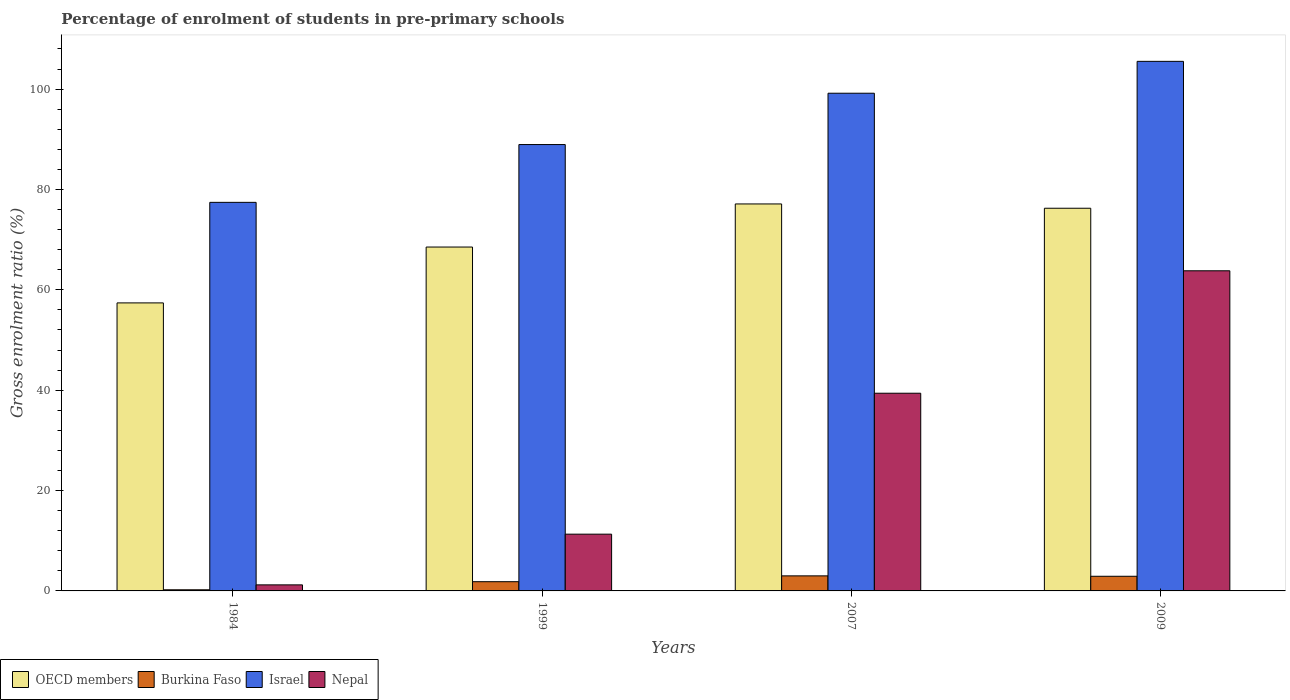How many groups of bars are there?
Make the answer very short. 4. Are the number of bars per tick equal to the number of legend labels?
Your response must be concise. Yes. Are the number of bars on each tick of the X-axis equal?
Offer a terse response. Yes. How many bars are there on the 1st tick from the left?
Your answer should be very brief. 4. How many bars are there on the 2nd tick from the right?
Your response must be concise. 4. What is the label of the 2nd group of bars from the left?
Keep it short and to the point. 1999. In how many cases, is the number of bars for a given year not equal to the number of legend labels?
Offer a very short reply. 0. What is the percentage of students enrolled in pre-primary schools in Israel in 1999?
Offer a terse response. 88.95. Across all years, what is the maximum percentage of students enrolled in pre-primary schools in OECD members?
Give a very brief answer. 77.11. Across all years, what is the minimum percentage of students enrolled in pre-primary schools in Israel?
Your response must be concise. 77.43. In which year was the percentage of students enrolled in pre-primary schools in Nepal minimum?
Offer a very short reply. 1984. What is the total percentage of students enrolled in pre-primary schools in Burkina Faso in the graph?
Your answer should be very brief. 7.98. What is the difference between the percentage of students enrolled in pre-primary schools in Nepal in 1999 and that in 2009?
Provide a short and direct response. -52.49. What is the difference between the percentage of students enrolled in pre-primary schools in Israel in 2007 and the percentage of students enrolled in pre-primary schools in Nepal in 1984?
Offer a very short reply. 97.97. What is the average percentage of students enrolled in pre-primary schools in Nepal per year?
Ensure brevity in your answer.  28.93. In the year 1984, what is the difference between the percentage of students enrolled in pre-primary schools in OECD members and percentage of students enrolled in pre-primary schools in Nepal?
Keep it short and to the point. 56.19. What is the ratio of the percentage of students enrolled in pre-primary schools in OECD members in 1984 to that in 1999?
Offer a terse response. 0.84. Is the percentage of students enrolled in pre-primary schools in Israel in 1999 less than that in 2009?
Your response must be concise. Yes. What is the difference between the highest and the second highest percentage of students enrolled in pre-primary schools in Israel?
Your answer should be very brief. 6.35. What is the difference between the highest and the lowest percentage of students enrolled in pre-primary schools in Burkina Faso?
Offer a terse response. 2.78. In how many years, is the percentage of students enrolled in pre-primary schools in Israel greater than the average percentage of students enrolled in pre-primary schools in Israel taken over all years?
Provide a short and direct response. 2. Is the sum of the percentage of students enrolled in pre-primary schools in Nepal in 1984 and 2007 greater than the maximum percentage of students enrolled in pre-primary schools in Israel across all years?
Provide a succinct answer. No. What does the 2nd bar from the left in 1999 represents?
Ensure brevity in your answer.  Burkina Faso. What does the 1st bar from the right in 1984 represents?
Your answer should be very brief. Nepal. Is it the case that in every year, the sum of the percentage of students enrolled in pre-primary schools in Israel and percentage of students enrolled in pre-primary schools in OECD members is greater than the percentage of students enrolled in pre-primary schools in Nepal?
Provide a succinct answer. Yes. Are all the bars in the graph horizontal?
Give a very brief answer. No. How many years are there in the graph?
Make the answer very short. 4. Does the graph contain any zero values?
Offer a terse response. No. How many legend labels are there?
Your answer should be very brief. 4. What is the title of the graph?
Your answer should be very brief. Percentage of enrolment of students in pre-primary schools. Does "Sudan" appear as one of the legend labels in the graph?
Ensure brevity in your answer.  No. What is the label or title of the Y-axis?
Offer a very short reply. Gross enrolment ratio (%). What is the Gross enrolment ratio (%) in OECD members in 1984?
Give a very brief answer. 57.4. What is the Gross enrolment ratio (%) in Burkina Faso in 1984?
Your answer should be very brief. 0.23. What is the Gross enrolment ratio (%) in Israel in 1984?
Make the answer very short. 77.43. What is the Gross enrolment ratio (%) in Nepal in 1984?
Keep it short and to the point. 1.21. What is the Gross enrolment ratio (%) in OECD members in 1999?
Give a very brief answer. 68.53. What is the Gross enrolment ratio (%) in Burkina Faso in 1999?
Your answer should be compact. 1.84. What is the Gross enrolment ratio (%) of Israel in 1999?
Keep it short and to the point. 88.95. What is the Gross enrolment ratio (%) of Nepal in 1999?
Keep it short and to the point. 11.31. What is the Gross enrolment ratio (%) of OECD members in 2007?
Keep it short and to the point. 77.11. What is the Gross enrolment ratio (%) of Burkina Faso in 2007?
Provide a succinct answer. 3. What is the Gross enrolment ratio (%) of Israel in 2007?
Ensure brevity in your answer.  99.18. What is the Gross enrolment ratio (%) in Nepal in 2007?
Offer a very short reply. 39.4. What is the Gross enrolment ratio (%) in OECD members in 2009?
Keep it short and to the point. 76.26. What is the Gross enrolment ratio (%) in Burkina Faso in 2009?
Offer a terse response. 2.92. What is the Gross enrolment ratio (%) of Israel in 2009?
Offer a terse response. 105.53. What is the Gross enrolment ratio (%) in Nepal in 2009?
Give a very brief answer. 63.8. Across all years, what is the maximum Gross enrolment ratio (%) of OECD members?
Provide a short and direct response. 77.11. Across all years, what is the maximum Gross enrolment ratio (%) in Burkina Faso?
Provide a short and direct response. 3. Across all years, what is the maximum Gross enrolment ratio (%) in Israel?
Provide a succinct answer. 105.53. Across all years, what is the maximum Gross enrolment ratio (%) of Nepal?
Keep it short and to the point. 63.8. Across all years, what is the minimum Gross enrolment ratio (%) in OECD members?
Provide a short and direct response. 57.4. Across all years, what is the minimum Gross enrolment ratio (%) in Burkina Faso?
Provide a succinct answer. 0.23. Across all years, what is the minimum Gross enrolment ratio (%) in Israel?
Provide a succinct answer. 77.43. Across all years, what is the minimum Gross enrolment ratio (%) of Nepal?
Provide a short and direct response. 1.21. What is the total Gross enrolment ratio (%) in OECD members in the graph?
Give a very brief answer. 279.3. What is the total Gross enrolment ratio (%) of Burkina Faso in the graph?
Your answer should be very brief. 7.98. What is the total Gross enrolment ratio (%) of Israel in the graph?
Give a very brief answer. 371.09. What is the total Gross enrolment ratio (%) of Nepal in the graph?
Offer a terse response. 115.71. What is the difference between the Gross enrolment ratio (%) in OECD members in 1984 and that in 1999?
Provide a succinct answer. -11.13. What is the difference between the Gross enrolment ratio (%) of Burkina Faso in 1984 and that in 1999?
Give a very brief answer. -1.61. What is the difference between the Gross enrolment ratio (%) in Israel in 1984 and that in 1999?
Provide a succinct answer. -11.52. What is the difference between the Gross enrolment ratio (%) of Nepal in 1984 and that in 1999?
Your response must be concise. -10.1. What is the difference between the Gross enrolment ratio (%) of OECD members in 1984 and that in 2007?
Your answer should be very brief. -19.72. What is the difference between the Gross enrolment ratio (%) of Burkina Faso in 1984 and that in 2007?
Ensure brevity in your answer.  -2.78. What is the difference between the Gross enrolment ratio (%) of Israel in 1984 and that in 2007?
Your answer should be compact. -21.74. What is the difference between the Gross enrolment ratio (%) of Nepal in 1984 and that in 2007?
Provide a succinct answer. -38.19. What is the difference between the Gross enrolment ratio (%) in OECD members in 1984 and that in 2009?
Your response must be concise. -18.86. What is the difference between the Gross enrolment ratio (%) in Burkina Faso in 1984 and that in 2009?
Your answer should be very brief. -2.69. What is the difference between the Gross enrolment ratio (%) of Israel in 1984 and that in 2009?
Provide a short and direct response. -28.1. What is the difference between the Gross enrolment ratio (%) in Nepal in 1984 and that in 2009?
Offer a terse response. -62.59. What is the difference between the Gross enrolment ratio (%) in OECD members in 1999 and that in 2007?
Your answer should be compact. -8.59. What is the difference between the Gross enrolment ratio (%) of Burkina Faso in 1999 and that in 2007?
Provide a succinct answer. -1.16. What is the difference between the Gross enrolment ratio (%) in Israel in 1999 and that in 2007?
Offer a terse response. -10.23. What is the difference between the Gross enrolment ratio (%) of Nepal in 1999 and that in 2007?
Offer a terse response. -28.09. What is the difference between the Gross enrolment ratio (%) of OECD members in 1999 and that in 2009?
Keep it short and to the point. -7.73. What is the difference between the Gross enrolment ratio (%) in Burkina Faso in 1999 and that in 2009?
Provide a short and direct response. -1.08. What is the difference between the Gross enrolment ratio (%) in Israel in 1999 and that in 2009?
Provide a succinct answer. -16.58. What is the difference between the Gross enrolment ratio (%) of Nepal in 1999 and that in 2009?
Provide a succinct answer. -52.49. What is the difference between the Gross enrolment ratio (%) in OECD members in 2007 and that in 2009?
Give a very brief answer. 0.86. What is the difference between the Gross enrolment ratio (%) in Burkina Faso in 2007 and that in 2009?
Your answer should be compact. 0.08. What is the difference between the Gross enrolment ratio (%) in Israel in 2007 and that in 2009?
Offer a very short reply. -6.35. What is the difference between the Gross enrolment ratio (%) in Nepal in 2007 and that in 2009?
Your answer should be compact. -24.4. What is the difference between the Gross enrolment ratio (%) in OECD members in 1984 and the Gross enrolment ratio (%) in Burkina Faso in 1999?
Your response must be concise. 55.56. What is the difference between the Gross enrolment ratio (%) of OECD members in 1984 and the Gross enrolment ratio (%) of Israel in 1999?
Offer a very short reply. -31.55. What is the difference between the Gross enrolment ratio (%) in OECD members in 1984 and the Gross enrolment ratio (%) in Nepal in 1999?
Keep it short and to the point. 46.09. What is the difference between the Gross enrolment ratio (%) of Burkina Faso in 1984 and the Gross enrolment ratio (%) of Israel in 1999?
Give a very brief answer. -88.72. What is the difference between the Gross enrolment ratio (%) of Burkina Faso in 1984 and the Gross enrolment ratio (%) of Nepal in 1999?
Keep it short and to the point. -11.08. What is the difference between the Gross enrolment ratio (%) in Israel in 1984 and the Gross enrolment ratio (%) in Nepal in 1999?
Give a very brief answer. 66.12. What is the difference between the Gross enrolment ratio (%) of OECD members in 1984 and the Gross enrolment ratio (%) of Burkina Faso in 2007?
Your response must be concise. 54.39. What is the difference between the Gross enrolment ratio (%) in OECD members in 1984 and the Gross enrolment ratio (%) in Israel in 2007?
Keep it short and to the point. -41.78. What is the difference between the Gross enrolment ratio (%) in OECD members in 1984 and the Gross enrolment ratio (%) in Nepal in 2007?
Your response must be concise. 18. What is the difference between the Gross enrolment ratio (%) of Burkina Faso in 1984 and the Gross enrolment ratio (%) of Israel in 2007?
Give a very brief answer. -98.95. What is the difference between the Gross enrolment ratio (%) in Burkina Faso in 1984 and the Gross enrolment ratio (%) in Nepal in 2007?
Offer a very short reply. -39.17. What is the difference between the Gross enrolment ratio (%) in Israel in 1984 and the Gross enrolment ratio (%) in Nepal in 2007?
Keep it short and to the point. 38.04. What is the difference between the Gross enrolment ratio (%) in OECD members in 1984 and the Gross enrolment ratio (%) in Burkina Faso in 2009?
Offer a terse response. 54.48. What is the difference between the Gross enrolment ratio (%) of OECD members in 1984 and the Gross enrolment ratio (%) of Israel in 2009?
Give a very brief answer. -48.13. What is the difference between the Gross enrolment ratio (%) of OECD members in 1984 and the Gross enrolment ratio (%) of Nepal in 2009?
Your answer should be compact. -6.4. What is the difference between the Gross enrolment ratio (%) in Burkina Faso in 1984 and the Gross enrolment ratio (%) in Israel in 2009?
Give a very brief answer. -105.3. What is the difference between the Gross enrolment ratio (%) in Burkina Faso in 1984 and the Gross enrolment ratio (%) in Nepal in 2009?
Give a very brief answer. -63.57. What is the difference between the Gross enrolment ratio (%) of Israel in 1984 and the Gross enrolment ratio (%) of Nepal in 2009?
Keep it short and to the point. 13.64. What is the difference between the Gross enrolment ratio (%) of OECD members in 1999 and the Gross enrolment ratio (%) of Burkina Faso in 2007?
Your response must be concise. 65.53. What is the difference between the Gross enrolment ratio (%) in OECD members in 1999 and the Gross enrolment ratio (%) in Israel in 2007?
Give a very brief answer. -30.65. What is the difference between the Gross enrolment ratio (%) of OECD members in 1999 and the Gross enrolment ratio (%) of Nepal in 2007?
Make the answer very short. 29.13. What is the difference between the Gross enrolment ratio (%) in Burkina Faso in 1999 and the Gross enrolment ratio (%) in Israel in 2007?
Offer a terse response. -97.34. What is the difference between the Gross enrolment ratio (%) in Burkina Faso in 1999 and the Gross enrolment ratio (%) in Nepal in 2007?
Offer a terse response. -37.56. What is the difference between the Gross enrolment ratio (%) of Israel in 1999 and the Gross enrolment ratio (%) of Nepal in 2007?
Ensure brevity in your answer.  49.55. What is the difference between the Gross enrolment ratio (%) of OECD members in 1999 and the Gross enrolment ratio (%) of Burkina Faso in 2009?
Provide a succinct answer. 65.61. What is the difference between the Gross enrolment ratio (%) in OECD members in 1999 and the Gross enrolment ratio (%) in Israel in 2009?
Offer a very short reply. -37. What is the difference between the Gross enrolment ratio (%) in OECD members in 1999 and the Gross enrolment ratio (%) in Nepal in 2009?
Offer a terse response. 4.73. What is the difference between the Gross enrolment ratio (%) in Burkina Faso in 1999 and the Gross enrolment ratio (%) in Israel in 2009?
Provide a succinct answer. -103.69. What is the difference between the Gross enrolment ratio (%) of Burkina Faso in 1999 and the Gross enrolment ratio (%) of Nepal in 2009?
Your answer should be very brief. -61.96. What is the difference between the Gross enrolment ratio (%) of Israel in 1999 and the Gross enrolment ratio (%) of Nepal in 2009?
Offer a very short reply. 25.15. What is the difference between the Gross enrolment ratio (%) of OECD members in 2007 and the Gross enrolment ratio (%) of Burkina Faso in 2009?
Keep it short and to the point. 74.2. What is the difference between the Gross enrolment ratio (%) of OECD members in 2007 and the Gross enrolment ratio (%) of Israel in 2009?
Offer a very short reply. -28.42. What is the difference between the Gross enrolment ratio (%) of OECD members in 2007 and the Gross enrolment ratio (%) of Nepal in 2009?
Give a very brief answer. 13.32. What is the difference between the Gross enrolment ratio (%) of Burkina Faso in 2007 and the Gross enrolment ratio (%) of Israel in 2009?
Give a very brief answer. -102.53. What is the difference between the Gross enrolment ratio (%) of Burkina Faso in 2007 and the Gross enrolment ratio (%) of Nepal in 2009?
Keep it short and to the point. -60.79. What is the difference between the Gross enrolment ratio (%) in Israel in 2007 and the Gross enrolment ratio (%) in Nepal in 2009?
Your response must be concise. 35.38. What is the average Gross enrolment ratio (%) of OECD members per year?
Provide a succinct answer. 69.82. What is the average Gross enrolment ratio (%) of Burkina Faso per year?
Make the answer very short. 2. What is the average Gross enrolment ratio (%) in Israel per year?
Provide a succinct answer. 92.77. What is the average Gross enrolment ratio (%) of Nepal per year?
Keep it short and to the point. 28.93. In the year 1984, what is the difference between the Gross enrolment ratio (%) of OECD members and Gross enrolment ratio (%) of Burkina Faso?
Offer a very short reply. 57.17. In the year 1984, what is the difference between the Gross enrolment ratio (%) of OECD members and Gross enrolment ratio (%) of Israel?
Your answer should be very brief. -20.04. In the year 1984, what is the difference between the Gross enrolment ratio (%) of OECD members and Gross enrolment ratio (%) of Nepal?
Give a very brief answer. 56.19. In the year 1984, what is the difference between the Gross enrolment ratio (%) of Burkina Faso and Gross enrolment ratio (%) of Israel?
Offer a terse response. -77.21. In the year 1984, what is the difference between the Gross enrolment ratio (%) of Burkina Faso and Gross enrolment ratio (%) of Nepal?
Make the answer very short. -0.98. In the year 1984, what is the difference between the Gross enrolment ratio (%) of Israel and Gross enrolment ratio (%) of Nepal?
Keep it short and to the point. 76.23. In the year 1999, what is the difference between the Gross enrolment ratio (%) of OECD members and Gross enrolment ratio (%) of Burkina Faso?
Ensure brevity in your answer.  66.69. In the year 1999, what is the difference between the Gross enrolment ratio (%) of OECD members and Gross enrolment ratio (%) of Israel?
Provide a short and direct response. -20.42. In the year 1999, what is the difference between the Gross enrolment ratio (%) in OECD members and Gross enrolment ratio (%) in Nepal?
Provide a succinct answer. 57.22. In the year 1999, what is the difference between the Gross enrolment ratio (%) in Burkina Faso and Gross enrolment ratio (%) in Israel?
Make the answer very short. -87.11. In the year 1999, what is the difference between the Gross enrolment ratio (%) in Burkina Faso and Gross enrolment ratio (%) in Nepal?
Your answer should be very brief. -9.47. In the year 1999, what is the difference between the Gross enrolment ratio (%) in Israel and Gross enrolment ratio (%) in Nepal?
Offer a terse response. 77.64. In the year 2007, what is the difference between the Gross enrolment ratio (%) in OECD members and Gross enrolment ratio (%) in Burkina Faso?
Keep it short and to the point. 74.11. In the year 2007, what is the difference between the Gross enrolment ratio (%) of OECD members and Gross enrolment ratio (%) of Israel?
Keep it short and to the point. -22.06. In the year 2007, what is the difference between the Gross enrolment ratio (%) in OECD members and Gross enrolment ratio (%) in Nepal?
Your answer should be very brief. 37.72. In the year 2007, what is the difference between the Gross enrolment ratio (%) in Burkina Faso and Gross enrolment ratio (%) in Israel?
Your answer should be compact. -96.18. In the year 2007, what is the difference between the Gross enrolment ratio (%) of Burkina Faso and Gross enrolment ratio (%) of Nepal?
Your answer should be compact. -36.39. In the year 2007, what is the difference between the Gross enrolment ratio (%) of Israel and Gross enrolment ratio (%) of Nepal?
Keep it short and to the point. 59.78. In the year 2009, what is the difference between the Gross enrolment ratio (%) of OECD members and Gross enrolment ratio (%) of Burkina Faso?
Provide a succinct answer. 73.34. In the year 2009, what is the difference between the Gross enrolment ratio (%) in OECD members and Gross enrolment ratio (%) in Israel?
Give a very brief answer. -29.27. In the year 2009, what is the difference between the Gross enrolment ratio (%) of OECD members and Gross enrolment ratio (%) of Nepal?
Keep it short and to the point. 12.46. In the year 2009, what is the difference between the Gross enrolment ratio (%) of Burkina Faso and Gross enrolment ratio (%) of Israel?
Offer a very short reply. -102.61. In the year 2009, what is the difference between the Gross enrolment ratio (%) in Burkina Faso and Gross enrolment ratio (%) in Nepal?
Ensure brevity in your answer.  -60.88. In the year 2009, what is the difference between the Gross enrolment ratio (%) in Israel and Gross enrolment ratio (%) in Nepal?
Keep it short and to the point. 41.73. What is the ratio of the Gross enrolment ratio (%) in OECD members in 1984 to that in 1999?
Your answer should be compact. 0.84. What is the ratio of the Gross enrolment ratio (%) of Burkina Faso in 1984 to that in 1999?
Offer a very short reply. 0.12. What is the ratio of the Gross enrolment ratio (%) of Israel in 1984 to that in 1999?
Keep it short and to the point. 0.87. What is the ratio of the Gross enrolment ratio (%) in Nepal in 1984 to that in 1999?
Make the answer very short. 0.11. What is the ratio of the Gross enrolment ratio (%) of OECD members in 1984 to that in 2007?
Provide a short and direct response. 0.74. What is the ratio of the Gross enrolment ratio (%) in Burkina Faso in 1984 to that in 2007?
Provide a short and direct response. 0.08. What is the ratio of the Gross enrolment ratio (%) in Israel in 1984 to that in 2007?
Your answer should be compact. 0.78. What is the ratio of the Gross enrolment ratio (%) of Nepal in 1984 to that in 2007?
Provide a short and direct response. 0.03. What is the ratio of the Gross enrolment ratio (%) of OECD members in 1984 to that in 2009?
Ensure brevity in your answer.  0.75. What is the ratio of the Gross enrolment ratio (%) of Burkina Faso in 1984 to that in 2009?
Your answer should be very brief. 0.08. What is the ratio of the Gross enrolment ratio (%) of Israel in 1984 to that in 2009?
Keep it short and to the point. 0.73. What is the ratio of the Gross enrolment ratio (%) of Nepal in 1984 to that in 2009?
Offer a terse response. 0.02. What is the ratio of the Gross enrolment ratio (%) of OECD members in 1999 to that in 2007?
Make the answer very short. 0.89. What is the ratio of the Gross enrolment ratio (%) in Burkina Faso in 1999 to that in 2007?
Your response must be concise. 0.61. What is the ratio of the Gross enrolment ratio (%) in Israel in 1999 to that in 2007?
Your answer should be compact. 0.9. What is the ratio of the Gross enrolment ratio (%) in Nepal in 1999 to that in 2007?
Your answer should be compact. 0.29. What is the ratio of the Gross enrolment ratio (%) in OECD members in 1999 to that in 2009?
Provide a short and direct response. 0.9. What is the ratio of the Gross enrolment ratio (%) of Burkina Faso in 1999 to that in 2009?
Provide a short and direct response. 0.63. What is the ratio of the Gross enrolment ratio (%) in Israel in 1999 to that in 2009?
Your response must be concise. 0.84. What is the ratio of the Gross enrolment ratio (%) of Nepal in 1999 to that in 2009?
Keep it short and to the point. 0.18. What is the ratio of the Gross enrolment ratio (%) of OECD members in 2007 to that in 2009?
Make the answer very short. 1.01. What is the ratio of the Gross enrolment ratio (%) in Burkina Faso in 2007 to that in 2009?
Your response must be concise. 1.03. What is the ratio of the Gross enrolment ratio (%) of Israel in 2007 to that in 2009?
Your answer should be compact. 0.94. What is the ratio of the Gross enrolment ratio (%) of Nepal in 2007 to that in 2009?
Ensure brevity in your answer.  0.62. What is the difference between the highest and the second highest Gross enrolment ratio (%) of OECD members?
Ensure brevity in your answer.  0.86. What is the difference between the highest and the second highest Gross enrolment ratio (%) of Burkina Faso?
Keep it short and to the point. 0.08. What is the difference between the highest and the second highest Gross enrolment ratio (%) in Israel?
Your response must be concise. 6.35. What is the difference between the highest and the second highest Gross enrolment ratio (%) in Nepal?
Give a very brief answer. 24.4. What is the difference between the highest and the lowest Gross enrolment ratio (%) of OECD members?
Make the answer very short. 19.72. What is the difference between the highest and the lowest Gross enrolment ratio (%) of Burkina Faso?
Make the answer very short. 2.78. What is the difference between the highest and the lowest Gross enrolment ratio (%) of Israel?
Offer a very short reply. 28.1. What is the difference between the highest and the lowest Gross enrolment ratio (%) of Nepal?
Keep it short and to the point. 62.59. 